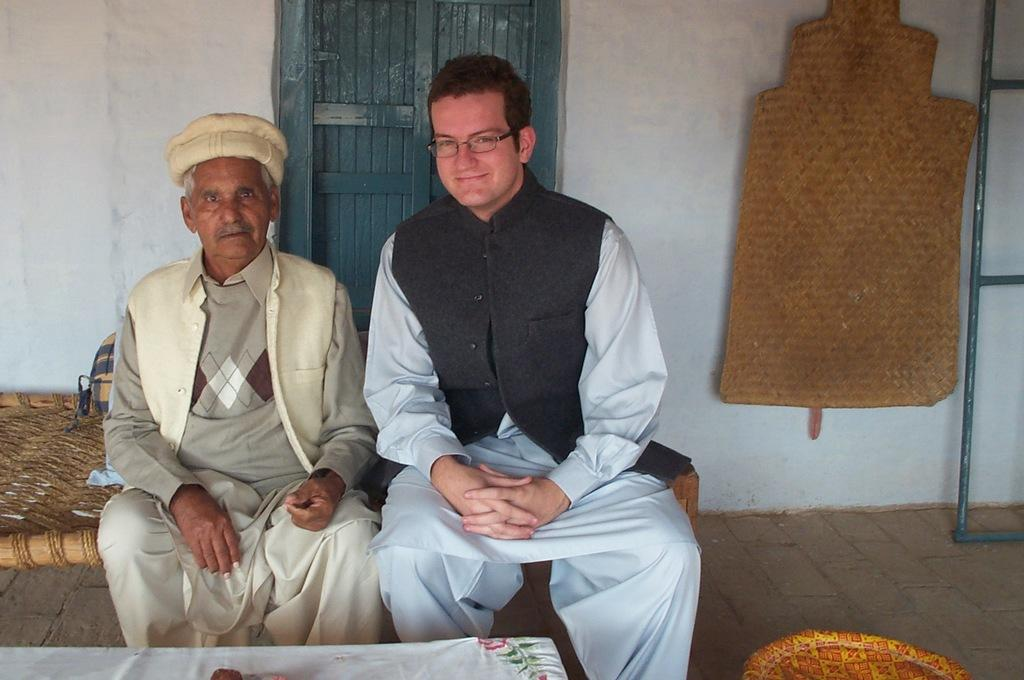How many people are sitting on the bed in the image? There are two men sitting on the bed in the image. What can be seen in the background of the image? There is a wall in the background of the image. What is unusual about the wall in the image? There is a doormat and an iron frame on the wall. What type of spring is visible on the bed in the image? There is no spring visible on the bed in the image. 